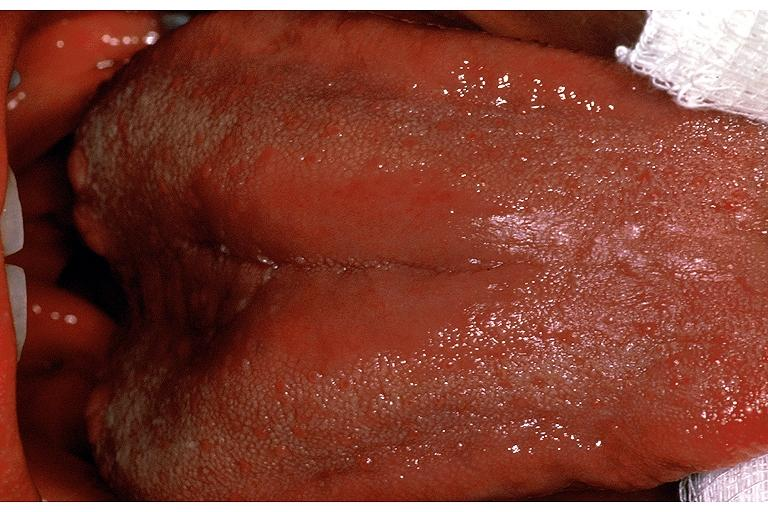does this image show median rhomboid glossitis?
Answer the question using a single word or phrase. Yes 